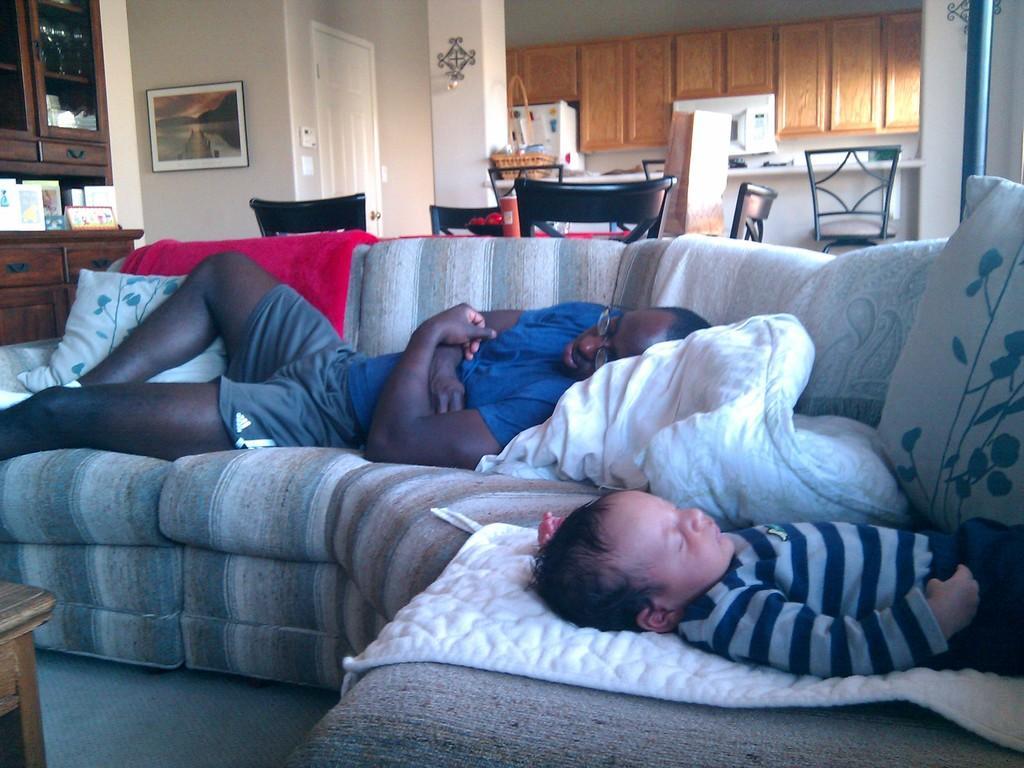Describe this image in one or two sentences. 2 persons are sleeping on the sofa. behind that there are chairs. at the left there are cupboards, photo frame and a white door. 